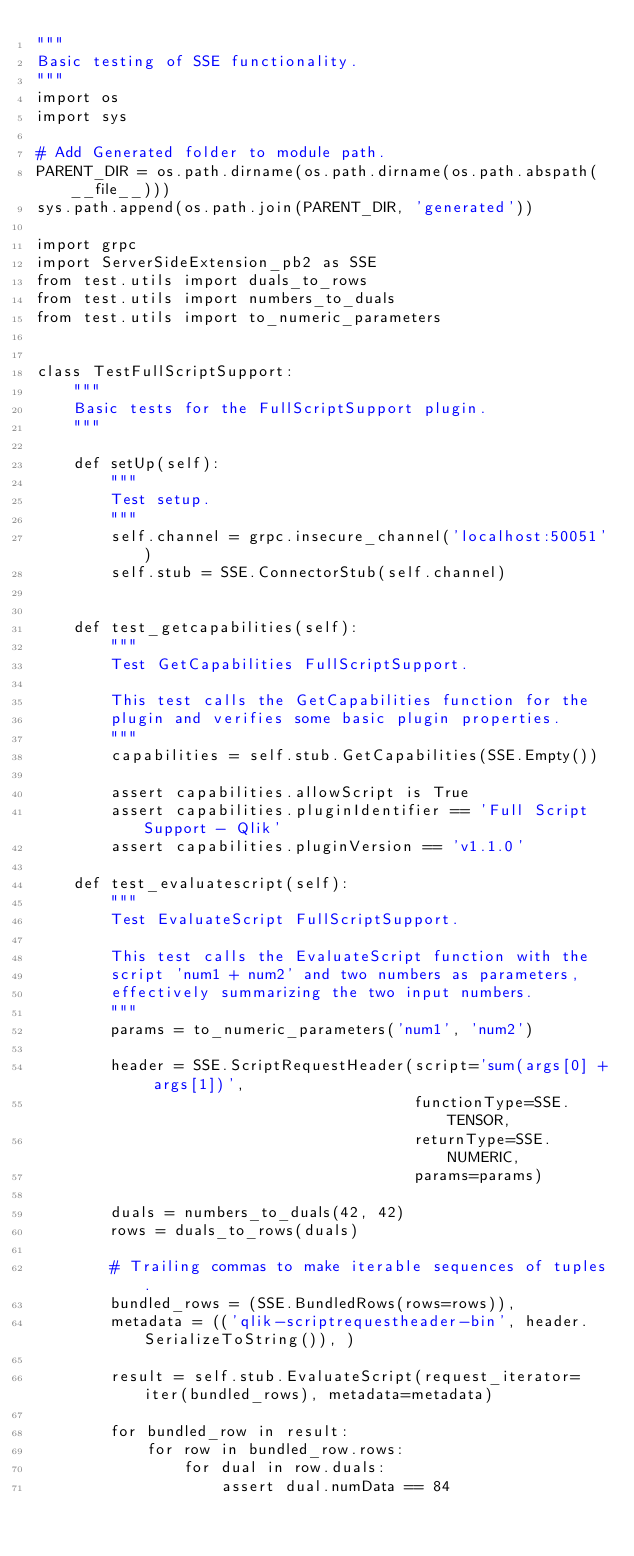<code> <loc_0><loc_0><loc_500><loc_500><_Python_>"""
Basic testing of SSE functionality.
"""
import os
import sys

# Add Generated folder to module path.
PARENT_DIR = os.path.dirname(os.path.dirname(os.path.abspath(__file__)))
sys.path.append(os.path.join(PARENT_DIR, 'generated'))

import grpc
import ServerSideExtension_pb2 as SSE
from test.utils import duals_to_rows
from test.utils import numbers_to_duals
from test.utils import to_numeric_parameters


class TestFullScriptSupport:
    """
    Basic tests for the FullScriptSupport plugin.
    """

    def setUp(self):
        """
        Test setup.
        """
        self.channel = grpc.insecure_channel('localhost:50051')
        self.stub = SSE.ConnectorStub(self.channel)


    def test_getcapabilities(self):
        """
        Test GetCapabilities FullScriptSupport.

        This test calls the GetCapabilities function for the
        plugin and verifies some basic plugin properties.
        """
        capabilities = self.stub.GetCapabilities(SSE.Empty())

        assert capabilities.allowScript is True
        assert capabilities.pluginIdentifier == 'Full Script Support - Qlik'
        assert capabilities.pluginVersion == 'v1.1.0'

    def test_evaluatescript(self):
        """
        Test EvaluateScript FullScriptSupport.

        This test calls the EvaluateScript function with the
        script 'num1 + num2' and two numbers as parameters,
        effectively summarizing the two input numbers.
        """
        params = to_numeric_parameters('num1', 'num2')

        header = SSE.ScriptRequestHeader(script='sum(args[0] + args[1])',
                                         functionType=SSE.TENSOR,
                                         returnType=SSE.NUMERIC,
                                         params=params)

        duals = numbers_to_duals(42, 42)
        rows = duals_to_rows(duals)

        # Trailing commas to make iterable sequences of tuples.
        bundled_rows = (SSE.BundledRows(rows=rows)),
        metadata = (('qlik-scriptrequestheader-bin', header.SerializeToString()), )

        result = self.stub.EvaluateScript(request_iterator=iter(bundled_rows), metadata=metadata)

        for bundled_row in result:
            for row in bundled_row.rows:
                for dual in row.duals:
                    assert dual.numData == 84
</code> 